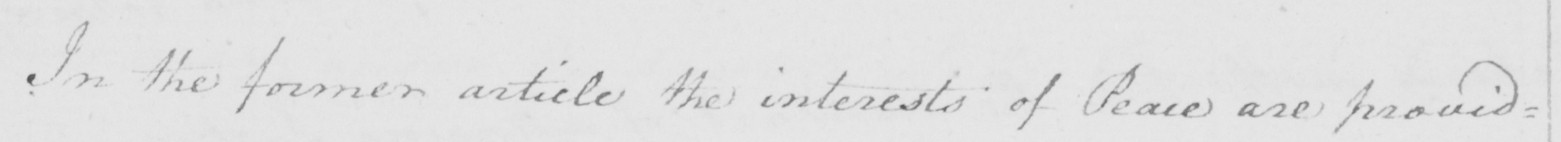What does this handwritten line say? In the former article the interests of Peace are provid= 